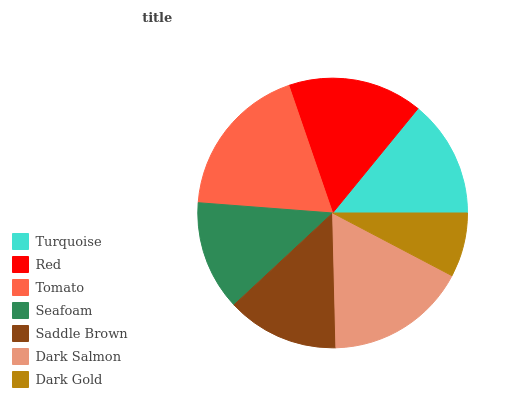Is Dark Gold the minimum?
Answer yes or no. Yes. Is Tomato the maximum?
Answer yes or no. Yes. Is Red the minimum?
Answer yes or no. No. Is Red the maximum?
Answer yes or no. No. Is Red greater than Turquoise?
Answer yes or no. Yes. Is Turquoise less than Red?
Answer yes or no. Yes. Is Turquoise greater than Red?
Answer yes or no. No. Is Red less than Turquoise?
Answer yes or no. No. Is Turquoise the high median?
Answer yes or no. Yes. Is Turquoise the low median?
Answer yes or no. Yes. Is Dark Salmon the high median?
Answer yes or no. No. Is Red the low median?
Answer yes or no. No. 